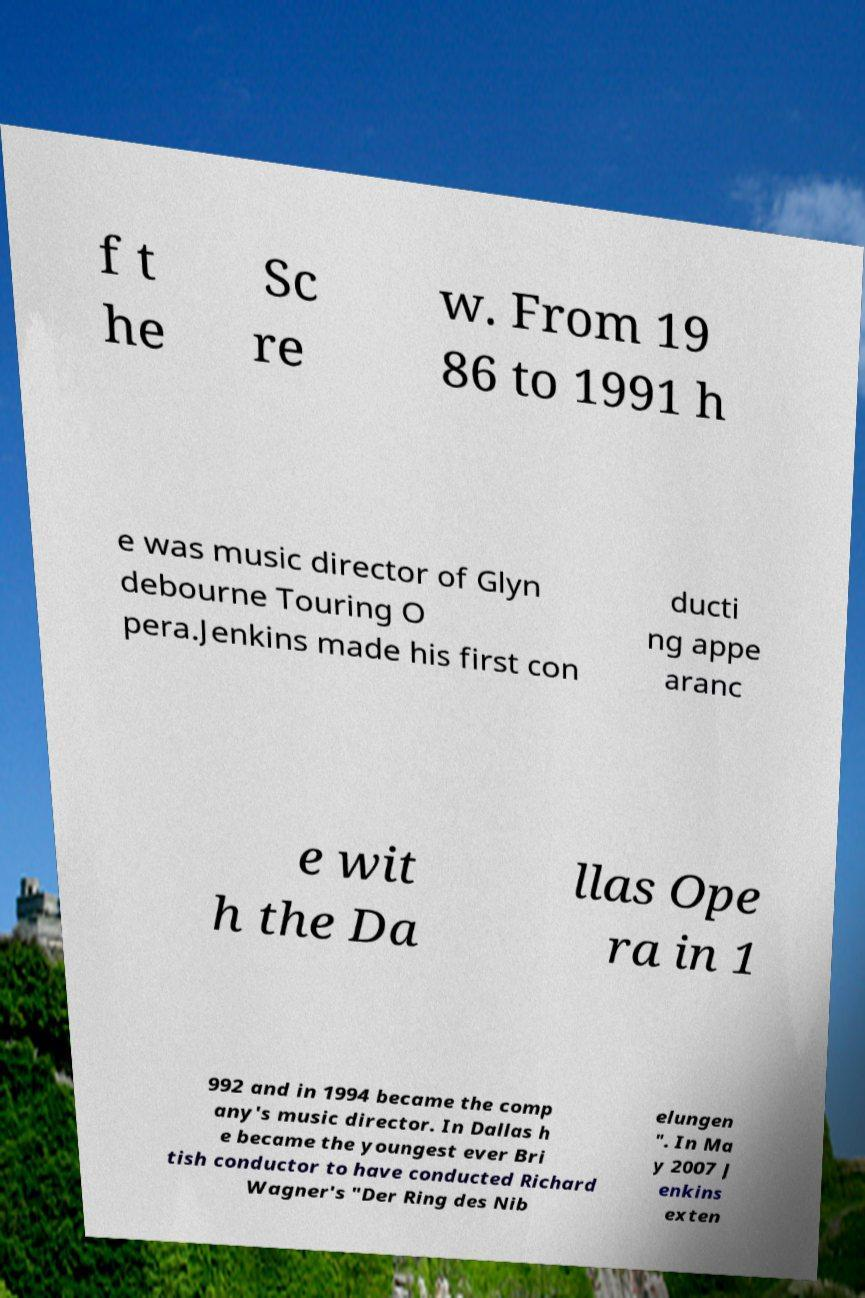Please identify and transcribe the text found in this image. f t he Sc re w. From 19 86 to 1991 h e was music director of Glyn debourne Touring O pera.Jenkins made his first con ducti ng appe aranc e wit h the Da llas Ope ra in 1 992 and in 1994 became the comp any's music director. In Dallas h e became the youngest ever Bri tish conductor to have conducted Richard Wagner's "Der Ring des Nib elungen ". In Ma y 2007 J enkins exten 